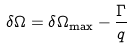<formula> <loc_0><loc_0><loc_500><loc_500>\delta \Omega = \delta \Omega _ { \max } - \frac { \Gamma } { q }</formula> 